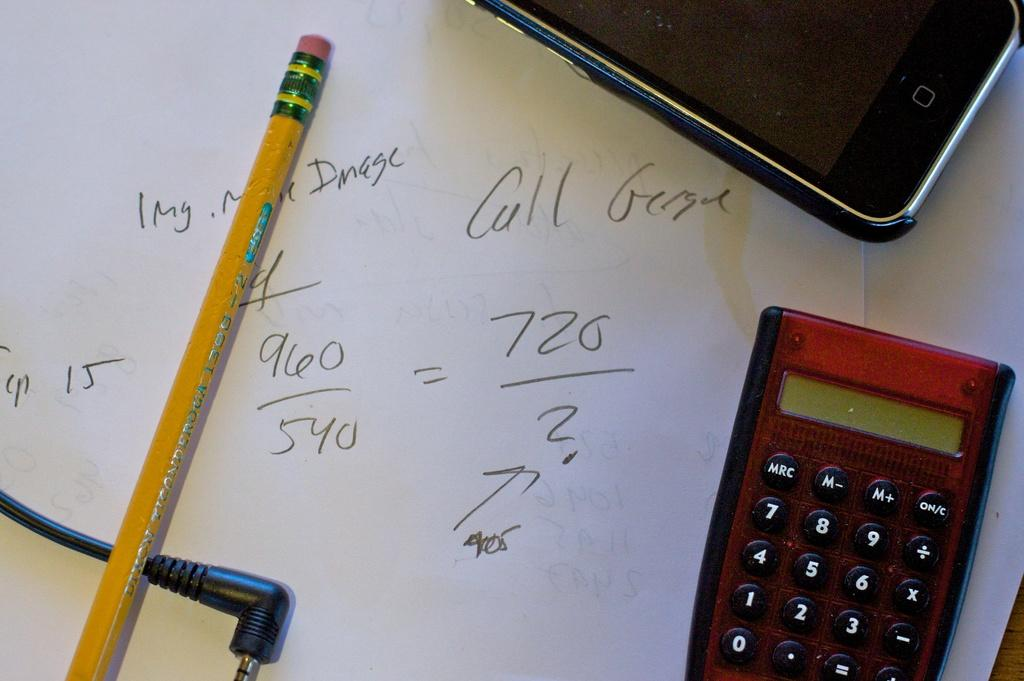<image>
Write a terse but informative summary of the picture. a paper with a 960 digit near the middle 